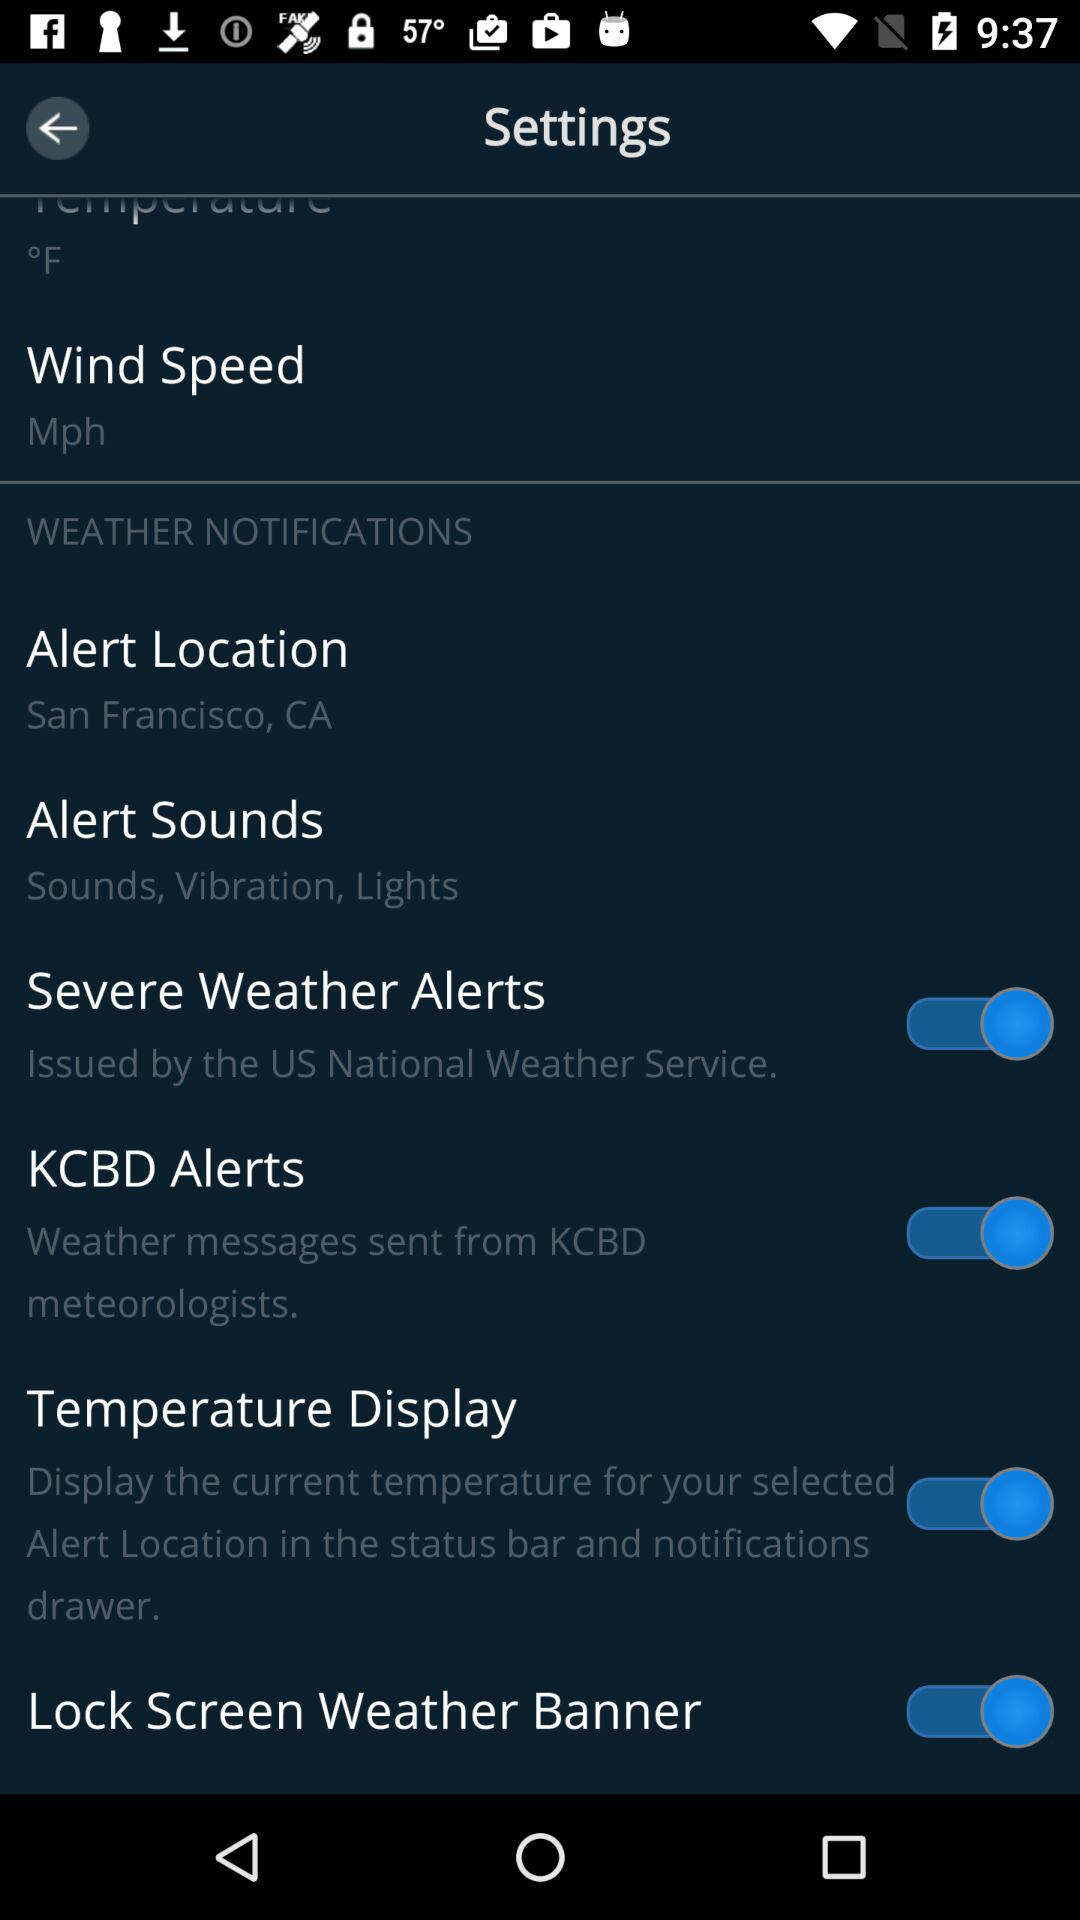How many items have a switch?
Answer the question using a single word or phrase. 4 